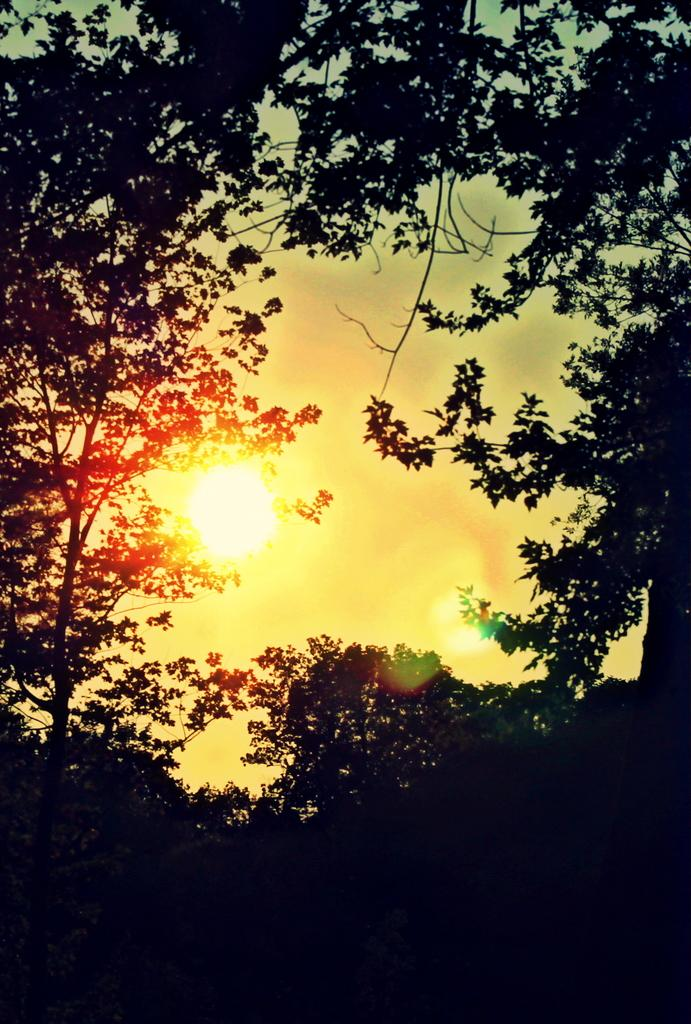What type of vegetation can be seen in the image? There are trees in the image. What celestial body is visible in the image? The sun is visible in the image. What else can be seen in the sky besides the sun? The sky is visible in the image, but no other celestial bodies or objects are mentioned in the provided facts. What day of the week is depicted in the image? The provided facts do not mention any specific day of the week, so it cannot be determined from the image. Can you see any ants in the image? There is no mention of ants in the provided facts, so it cannot be determined if they are present in the image. 